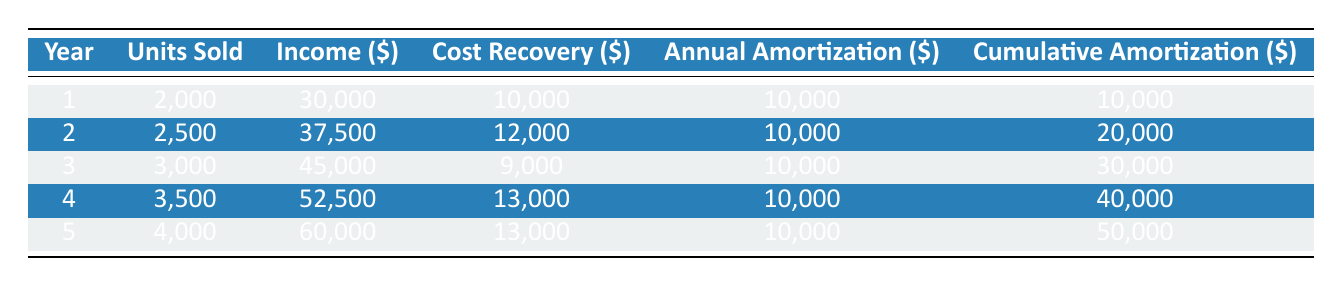What is the total production cost of the book? The table states that the total production cost of the book is listed at the beginning of the data. It mentions a total production cost of $50,000.
Answer: 50000 In which year were the highest income and units sold achieved? By examining the "Income" and "Units Sold" columns in the table, year 5 shows the highest units sold (4,000) and the highest income ($60,000).
Answer: Year 5 What is the total cost recovery over the five years? To find the total cost recovery, sum the cost recovery amounts for each year: 10,000 + 12,000 + 9,000 + 13,000 + 13,000 = 57,000.
Answer: 57000 Is the cumulative amortization equal to the total production cost at the end of the amortization period? The cumulative amortization for year 5 is $50,000, which matches the total production cost mentioned at the start, confirming that they are equal.
Answer: Yes What is the average annual amortization per year? Since the amortization period is 5 years and the annual amortization is $10,000 for each year, the average would be $10,000 (which is constant for all years).
Answer: 10000 Which year had the lowest cost recovery and how much was it? The lowest cost recovery is found in year 3, where the cumulative cost recovery is $9,000.
Answer: Year 3, $9000 How much cumulative amortization was achieved by year 4? Looking at the cumulative amortization column, for year 4, it shows that the total amortization achieved by that year is $40,000.
Answer: 40000 Calculate the difference in income between year 5 and year 1. To find the difference, subtract the income of year 1 ($30,000) from that of year 5 ($60,000): $60,000 - $30,000 = $30,000.
Answer: 30000 Did the book production recover more than its annual amortization during the entire 5-year period? By reviewing the cost recovery and total amortization, the total cost recovery is $57,000, which is greater than the total amortization of $50,000, indicating recovery more than the amortization.
Answer: Yes 